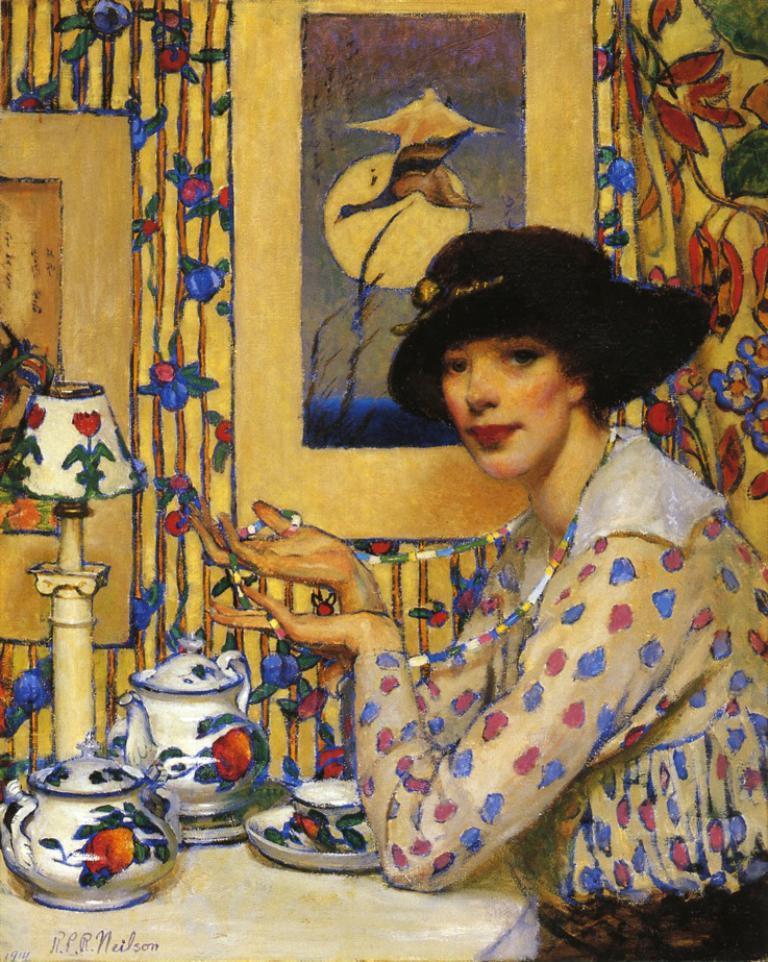Please provide a concise description of this image. In this image we can see the painting of a woman sitting holding a chain beside a table containing some teapots, plate and a bowl on it. We can also see a lamp and a photo frame to a wall. 